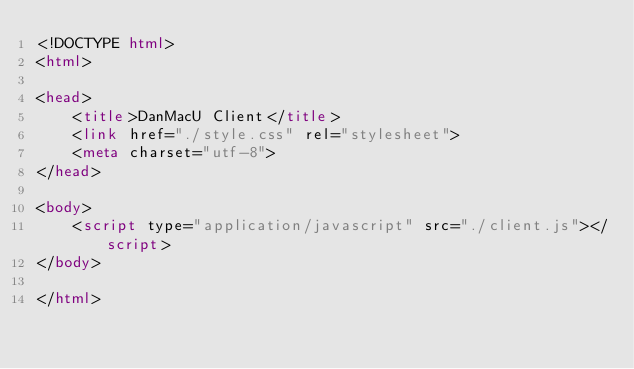Convert code to text. <code><loc_0><loc_0><loc_500><loc_500><_HTML_><!DOCTYPE html>
<html>

<head>
    <title>DanMacU Client</title>
    <link href="./style.css" rel="stylesheet">
    <meta charset="utf-8">
</head>

<body>
    <script type="application/javascript" src="./client.js"></script>
</body>

</html>
</code> 